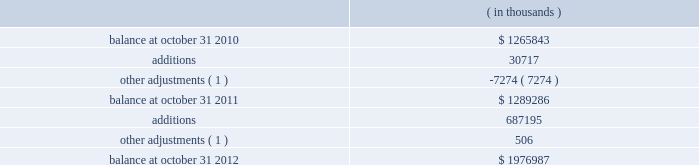Synopsys , inc .
Notes to consolidated financial statements 2014continued purchase price allocation .
The company allocated the total purchase consideration of $ 316.6 million ( including $ 4.6 million related to stock awards assumed ) to the assets acquired and liabilities assumed based on their respective fair values at the acquisition dates , including acquired identifiable intangible assets of $ 96.7 million and ipr&d of $ 13.2 million , resulting in total goodwill of $ 210.1 million .
Acquisition-related costs , consisting of professional services , severance costs , contract terminations and facilities closure costs , totaling $ 13.0 million were expensed as incurred in the consolidated statements of operations .
Goodwill primarily resulted from the company 2019s expectation of sales growth and cost synergies from the integration of virage 2019s technology with the company 2019s technology and operations to provide an expansion of products and market reach .
Identifiable intangible assets consisted of technology , customer relationships , contract rights and trademarks , were valued using the income method , and are being amortized over two to ten years .
Fair value of stock awards assumed .
The company assumed unvested restricted stock units ( rsus ) and stock appreciation rights ( sars ) with a fair value of $ 21.7 million .
Of the total consideration , $ 4.6 million was allocated to the purchase consideration and $ 17.1 million was allocated to future services and expensed over their remaining service periods on a straight-line basis .
Other fiscal 2010 acquisitions during fiscal 2010 , the company completed seven other acquisitions for cash .
The company allocated the total purchase consideration of $ 221.7 million to the assets acquired and liabilities assumed based on their respective fair values at the acquisition dates , resulting in total goodwill of $ 110.8 million .
Acquired identifiable intangible assets totaling $ 92.8 million are being amortized over their respective useful lives ranging from one to ten years .
Acquisition-related costs totaling $ 10.6 million were expensed as incurred in the consolidated statements of operations .
The purchase consideration for one of the acquisitions included contingent consideration up to $ 10.0 million payable upon the achievement of certain technology milestones over three years .
The contingent consideration was recorded as a liability at its estimated fair value determined based on the net present value of estimated payments of $ 7.8 million on the acquisition date and is being remeasured at fair value quarterly during the three-year contingency period with changes in its fair value recorded in the company 2019s statements of operations .
There is no contingent consideration liability as of the end of fiscal 2012 relating to this acquisition .
Note 4 .
Goodwill and intangible assets goodwill consists of the following: .
( 1 ) adjustments primarily relate to changes in estimates for acquisitions that closed in the prior fiscal year for which the purchase price allocation was still preliminary , and achievement of certain milestones for an acquisition that closed prior to fiscal 2010. .
What was the net change in thousands of the goodwill and intangible assets balance from october 31 , 2011 to october 31 , 2012? 
Computations: (1976987 - 1289286)
Answer: 687701.0. 